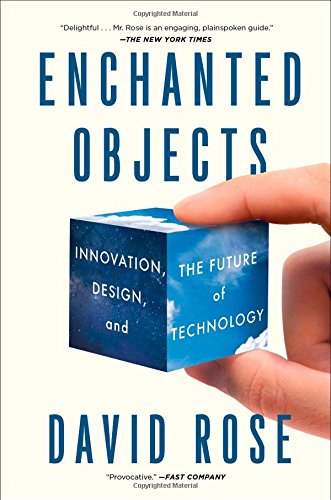What is the title of this book? The title of the book is 'Enchanted Objects: Innovation, Design, and the Future of Technology,' which hints at a thought-provoking exploration of the intersection of everyday items with advanced technology. 